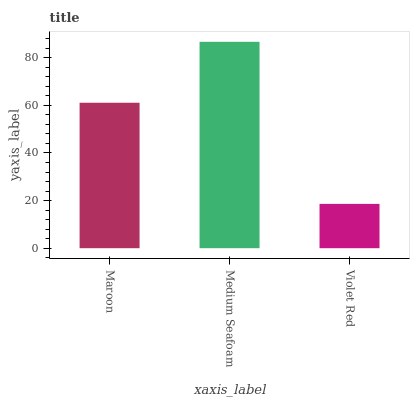Is Violet Red the minimum?
Answer yes or no. Yes. Is Medium Seafoam the maximum?
Answer yes or no. Yes. Is Medium Seafoam the minimum?
Answer yes or no. No. Is Violet Red the maximum?
Answer yes or no. No. Is Medium Seafoam greater than Violet Red?
Answer yes or no. Yes. Is Violet Red less than Medium Seafoam?
Answer yes or no. Yes. Is Violet Red greater than Medium Seafoam?
Answer yes or no. No. Is Medium Seafoam less than Violet Red?
Answer yes or no. No. Is Maroon the high median?
Answer yes or no. Yes. Is Maroon the low median?
Answer yes or no. Yes. Is Medium Seafoam the high median?
Answer yes or no. No. Is Medium Seafoam the low median?
Answer yes or no. No. 